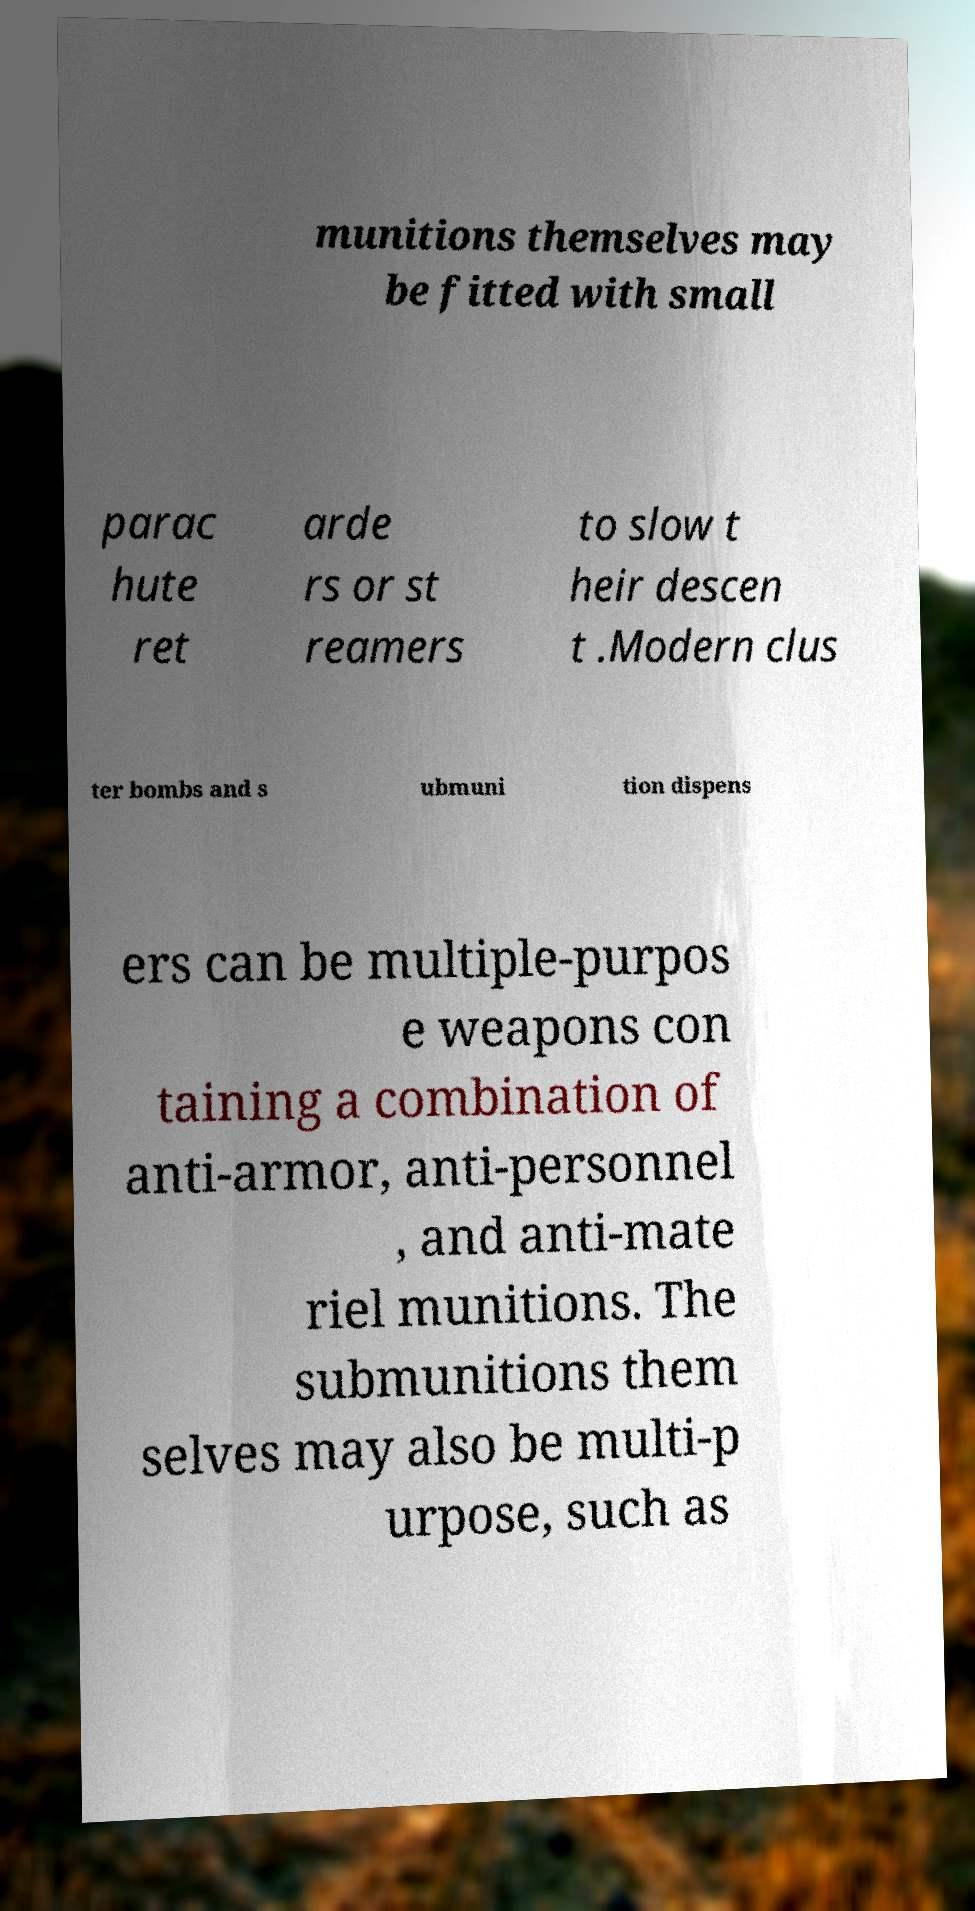Can you accurately transcribe the text from the provided image for me? munitions themselves may be fitted with small parac hute ret arde rs or st reamers to slow t heir descen t .Modern clus ter bombs and s ubmuni tion dispens ers can be multiple-purpos e weapons con taining a combination of anti-armor, anti-personnel , and anti-mate riel munitions. The submunitions them selves may also be multi-p urpose, such as 